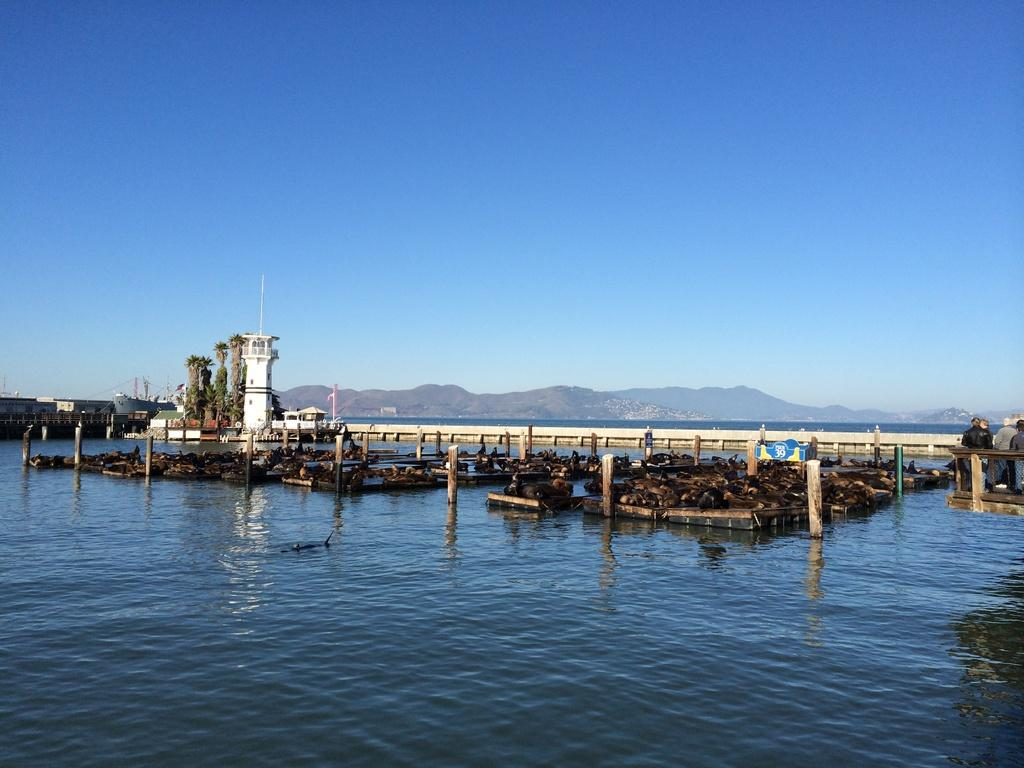What is at the bottom of the image? There is a surface of water at the bottom of the image. What structure can be seen in the image? There is a bridge in the image. What supports the bridge in the image? There are pillars in the image that support the bridge. What natural feature is visible in the image? There are mountains in the image. What is visible in the background of the image? The sky is visible in the background of the image. How many eggs are being used to build the bridge in the image? There are no eggs present in the image; the bridge is supported by pillars. What type of headwear is the mountain wearing in the image? There are no people or headwear present in the image, as it features a bridge, pillars, mountains, and water. 